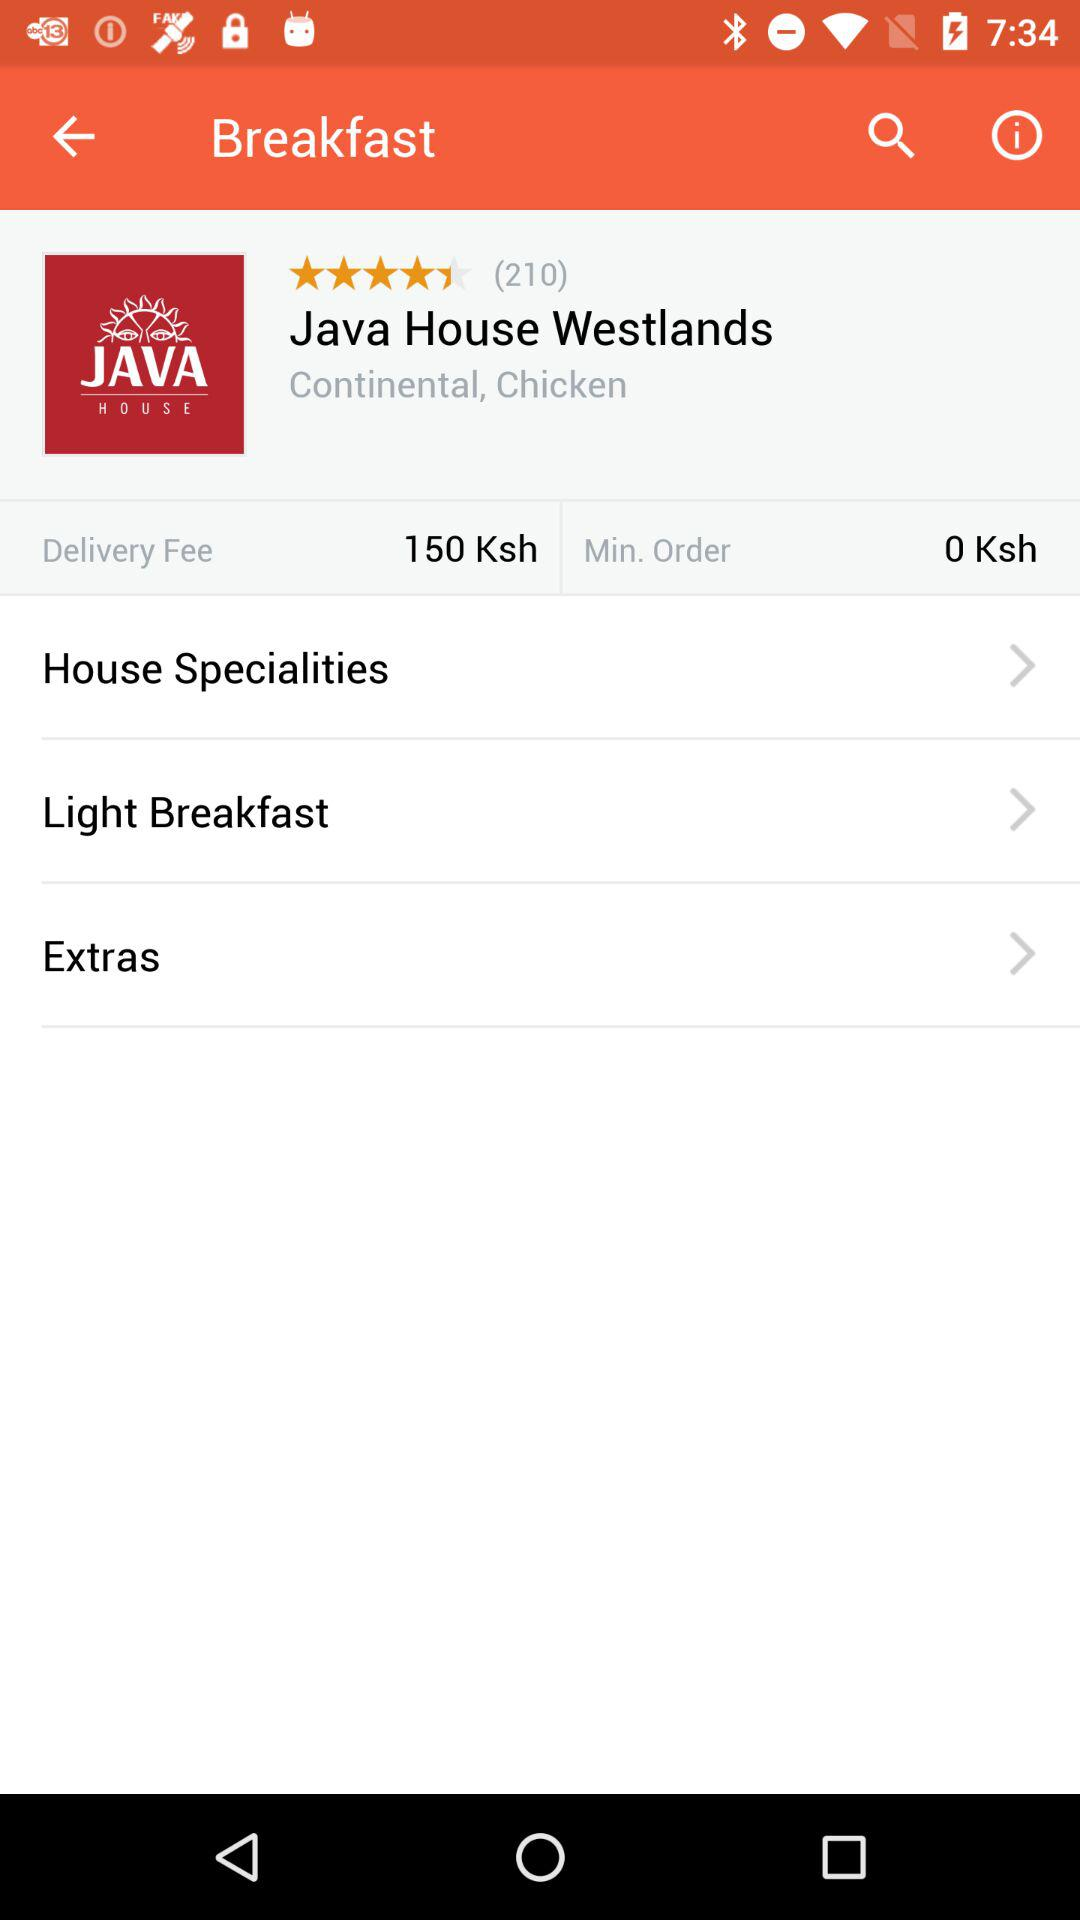How many stars are given? The given stars are 4.5. 